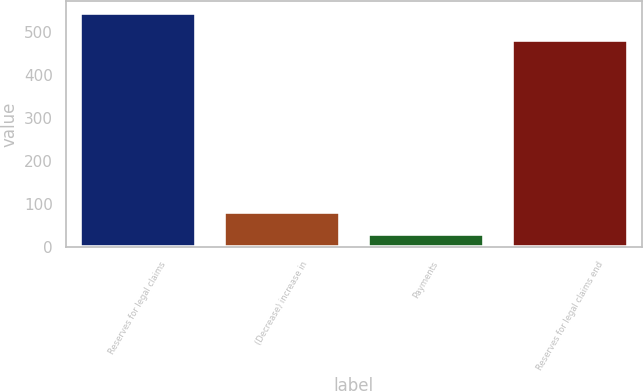Convert chart. <chart><loc_0><loc_0><loc_500><loc_500><bar_chart><fcel>Reserves for legal claims<fcel>(Decrease) increase in<fcel>Payments<fcel>Reserves for legal claims end<nl><fcel>544.9<fcel>79.96<fcel>28.3<fcel>482<nl></chart> 